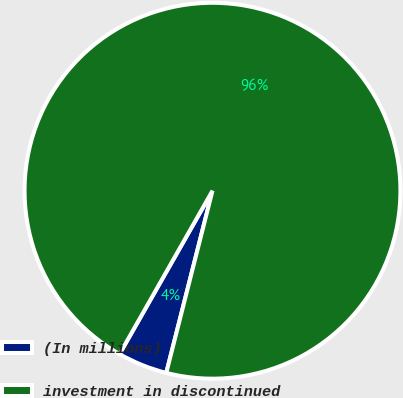Convert chart. <chart><loc_0><loc_0><loc_500><loc_500><pie_chart><fcel>(In millions)<fcel>investment in discontinued<nl><fcel>4.28%<fcel>95.72%<nl></chart> 